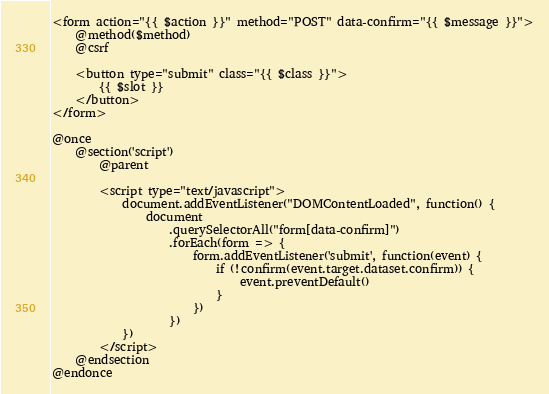<code> <loc_0><loc_0><loc_500><loc_500><_PHP_><form action="{{ $action }}" method="POST" data-confirm="{{ $message }}">
    @method($method)
    @csrf

    <button type="submit" class="{{ $class }}">
        {{ $slot }}
    </button>
</form>

@once
    @section('script')
        @parent

        <script type="text/javascript">
            document.addEventListener("DOMContentLoaded", function() {
                document
                    .querySelectorAll("form[data-confirm]")
                    .forEach(form => {
                        form.addEventListener('submit', function(event) {
                            if (!confirm(event.target.dataset.confirm)) {
                                event.preventDefault()
                            }
                        })
                    })
            })
        </script>
    @endsection
@endonce
</code> 